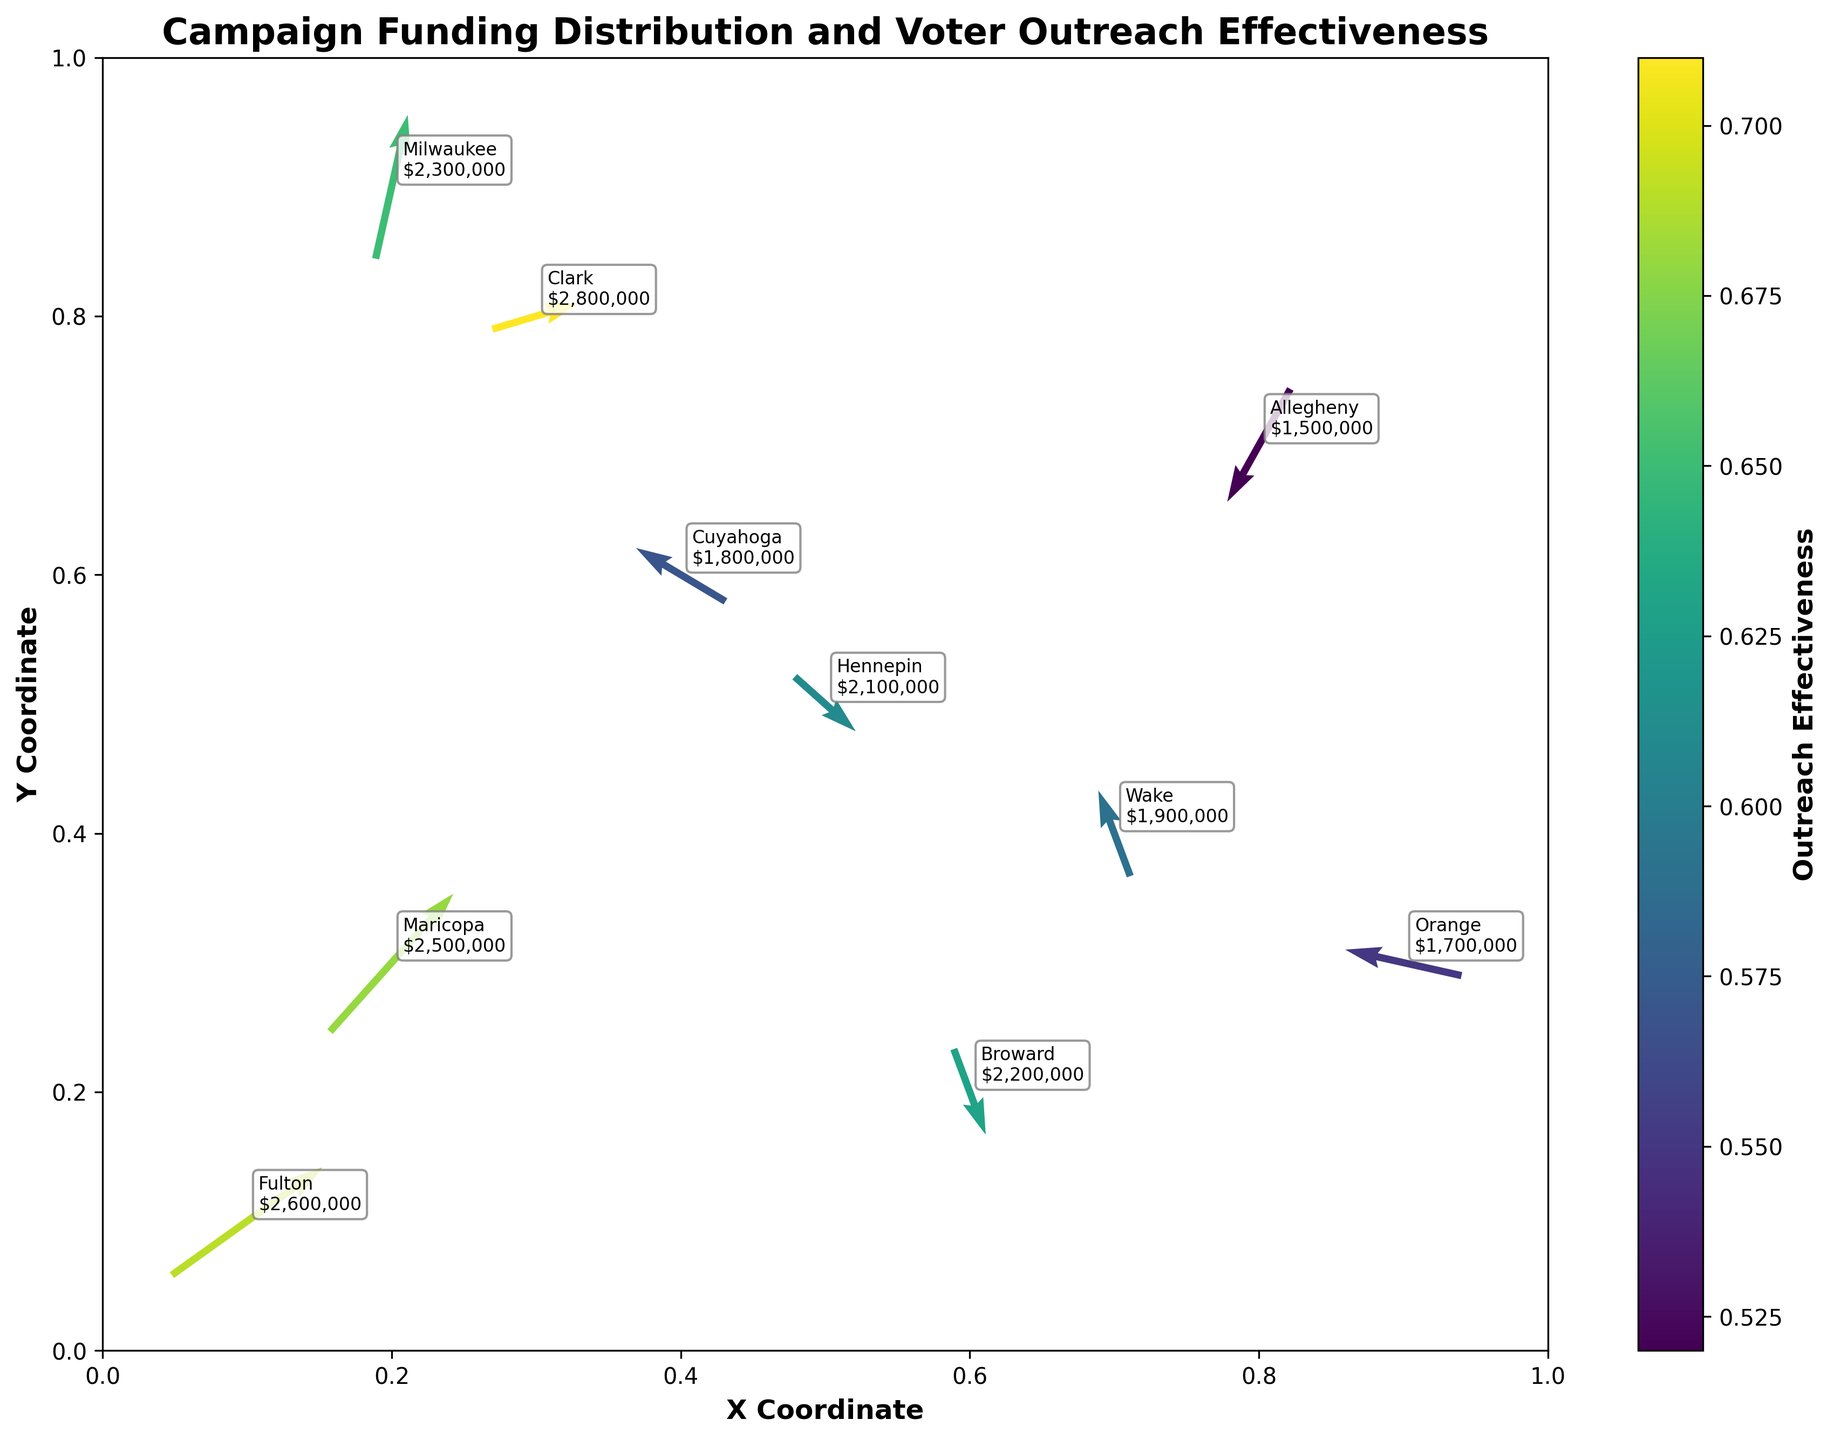What's the title of the figure? The title is usually placed at the top of the figure. In this case, the title is centered above the plot and reads "Campaign Funding Distribution and Voter Outreach Effectiveness".
Answer: Campaign Funding Distribution and Voter Outreach Effectiveness What do the axes labels represent? The labels on the x-axis and y-axis are written as "X Coordinate" and "Y Coordinate" respectively. These represent the positions of the counties in the plot.
Answer: X Coordinate and Y Coordinate How many data points are shown in the figure? Each data point corresponds to a quiver arrow in the figure. By counting the quiver arrows, we find there are 10 data points in total.
Answer: 10 Which county shows the highest voter outreach effectiveness? The color gradient of the quiver arrows indicates outreach effectiveness, with brighter colors typically showing higher values. Fulton County's arrow is significantly bright, representing the highest outreach effectiveness of 0.69.
Answer: Fulton What is the funding amount for Cuyahoga County? We locate the quiver arrow labeled with "Cuyahoga” and next to it, we see the funding amount written. For Cuyahoga, it shows $1,800,000.
Answer: $1,800,000 Which county has the longest quiver arrow and what does it indicate? By visual inspection, Fulton County has the longest quiver arrow. The length of the arrow represents the magnitude of change or influence in both the X and Y directions. A longer arrow generally indicates a higher effect.
Answer: Fulton Compare the funding between Clark County and Wake County. Which one has more funding? Inspecting both annotations on the plot shows that Clark County has $2,800,000 while Wake County has $1,900,000. Thus, Clark County has more funding.
Answer: Clark Which county shows a negative change in both X and Y directions? We need to identify the arrows pointing left and down (negative U and V values). Allegheny County has an arrow pointing left and down, indicating negative change in both directions.
Answer: Allegheny What is the average outreach effectiveness among all counties? To find the average, sum all the outreach effectiveness values (0.68, 0.57, 0.63, 0.52, 0.71, 0.59, 0.61, 0.69, 0.55, 0.65) and divide by the number of counties (10). Sum = 6.20; Average = 6.20/10 = 0.62.
Answer: 0.62 Which county has a quiver arrow pointing near vertically upwards, and what does that imply about its change in the X and Y directions? A near-vertical upwards arrow means minimal change in X-direction and significant positive change in Y-direction. Milwaukee has such an arrow, indicating it has minimal movement horizontally but a notable increase vertically upwards.
Answer: Milwaukee 